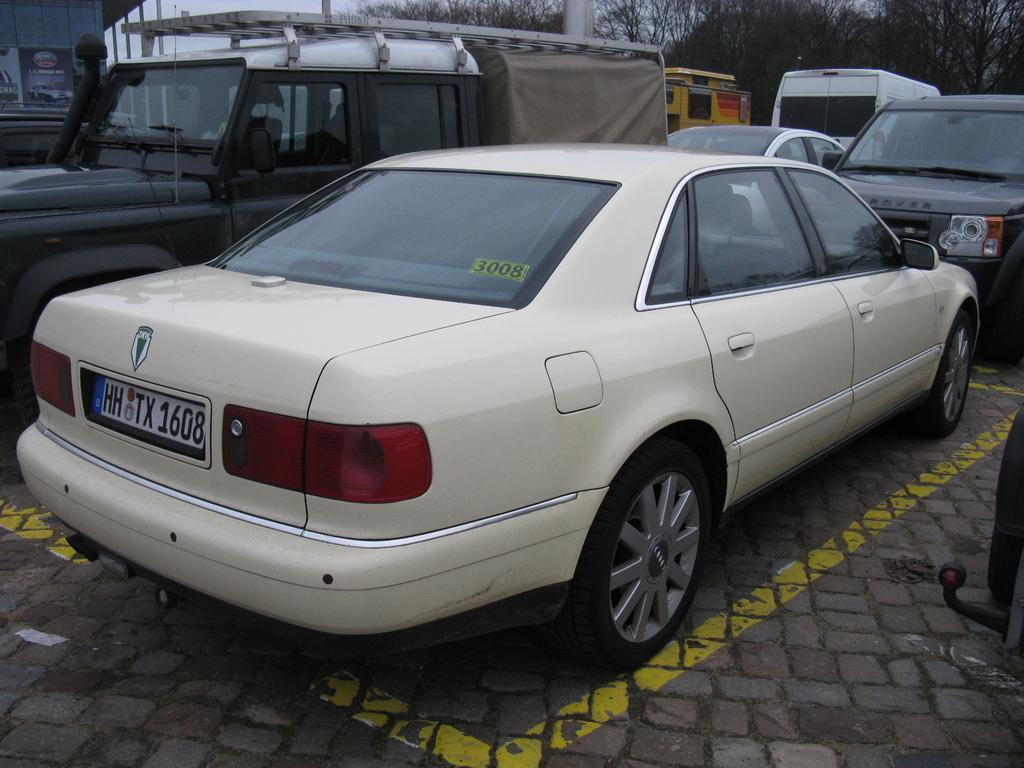What types of vehicles can be seen in the image? There are different vehicles in the image. Where are the vehicles located in the image? The vehicles are parked in an area. What can be seen in the background of the image? There are trees in the background of the image. What type of scarf is being used to control the behavior of the quiver in the image? There is no scarf, behavior, or quiver present in the image. 